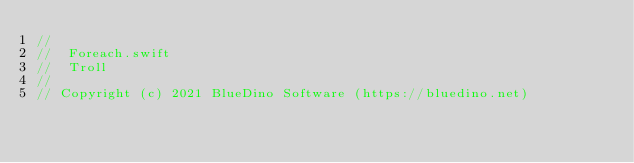Convert code to text. <code><loc_0><loc_0><loc_500><loc_500><_Swift_>//
//  Foreach.swift
//  Troll
//
// Copyright (c) 2021 BlueDino Software (https://bluedino.net)</code> 